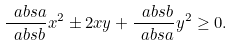<formula> <loc_0><loc_0><loc_500><loc_500>\frac { \ a b s { a } } { \ a b s { b } } x ^ { 2 } \pm 2 x y + \frac { \ a b s { b } } { \ a b s { a } } y ^ { 2 } \geq 0 .</formula> 